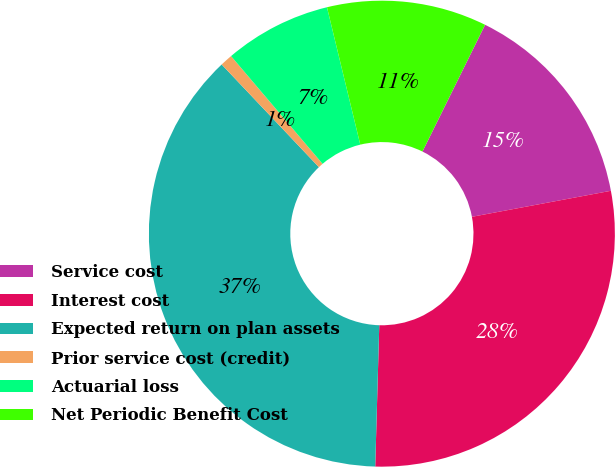Convert chart to OTSL. <chart><loc_0><loc_0><loc_500><loc_500><pie_chart><fcel>Service cost<fcel>Interest cost<fcel>Expected return on plan assets<fcel>Prior service cost (credit)<fcel>Actuarial loss<fcel>Net Periodic Benefit Cost<nl><fcel>14.75%<fcel>28.4%<fcel>37.48%<fcel>0.86%<fcel>7.42%<fcel>11.09%<nl></chart> 